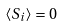<formula> <loc_0><loc_0><loc_500><loc_500>\langle { S } _ { i } \rangle = 0</formula> 